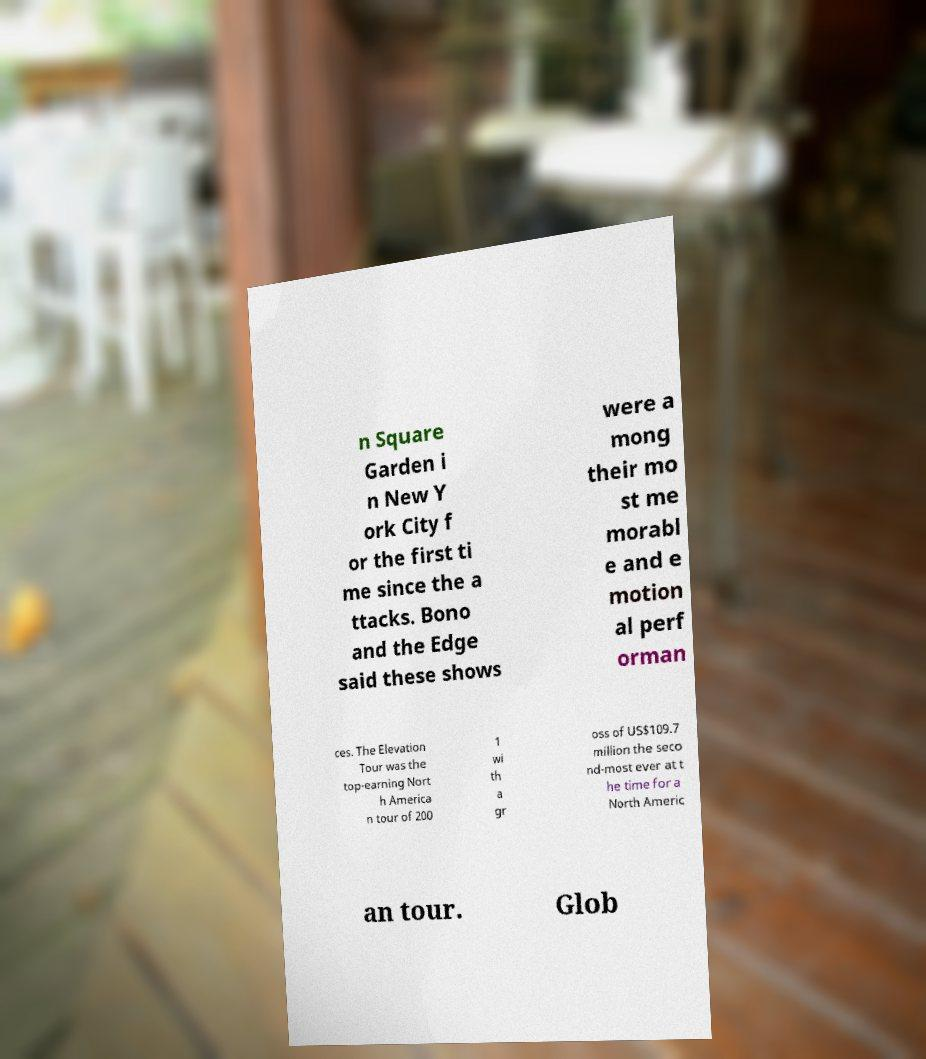There's text embedded in this image that I need extracted. Can you transcribe it verbatim? n Square Garden i n New Y ork City f or the first ti me since the a ttacks. Bono and the Edge said these shows were a mong their mo st me morabl e and e motion al perf orman ces. The Elevation Tour was the top-earning Nort h America n tour of 200 1 wi th a gr oss of US$109.7 million the seco nd-most ever at t he time for a North Americ an tour. Glob 